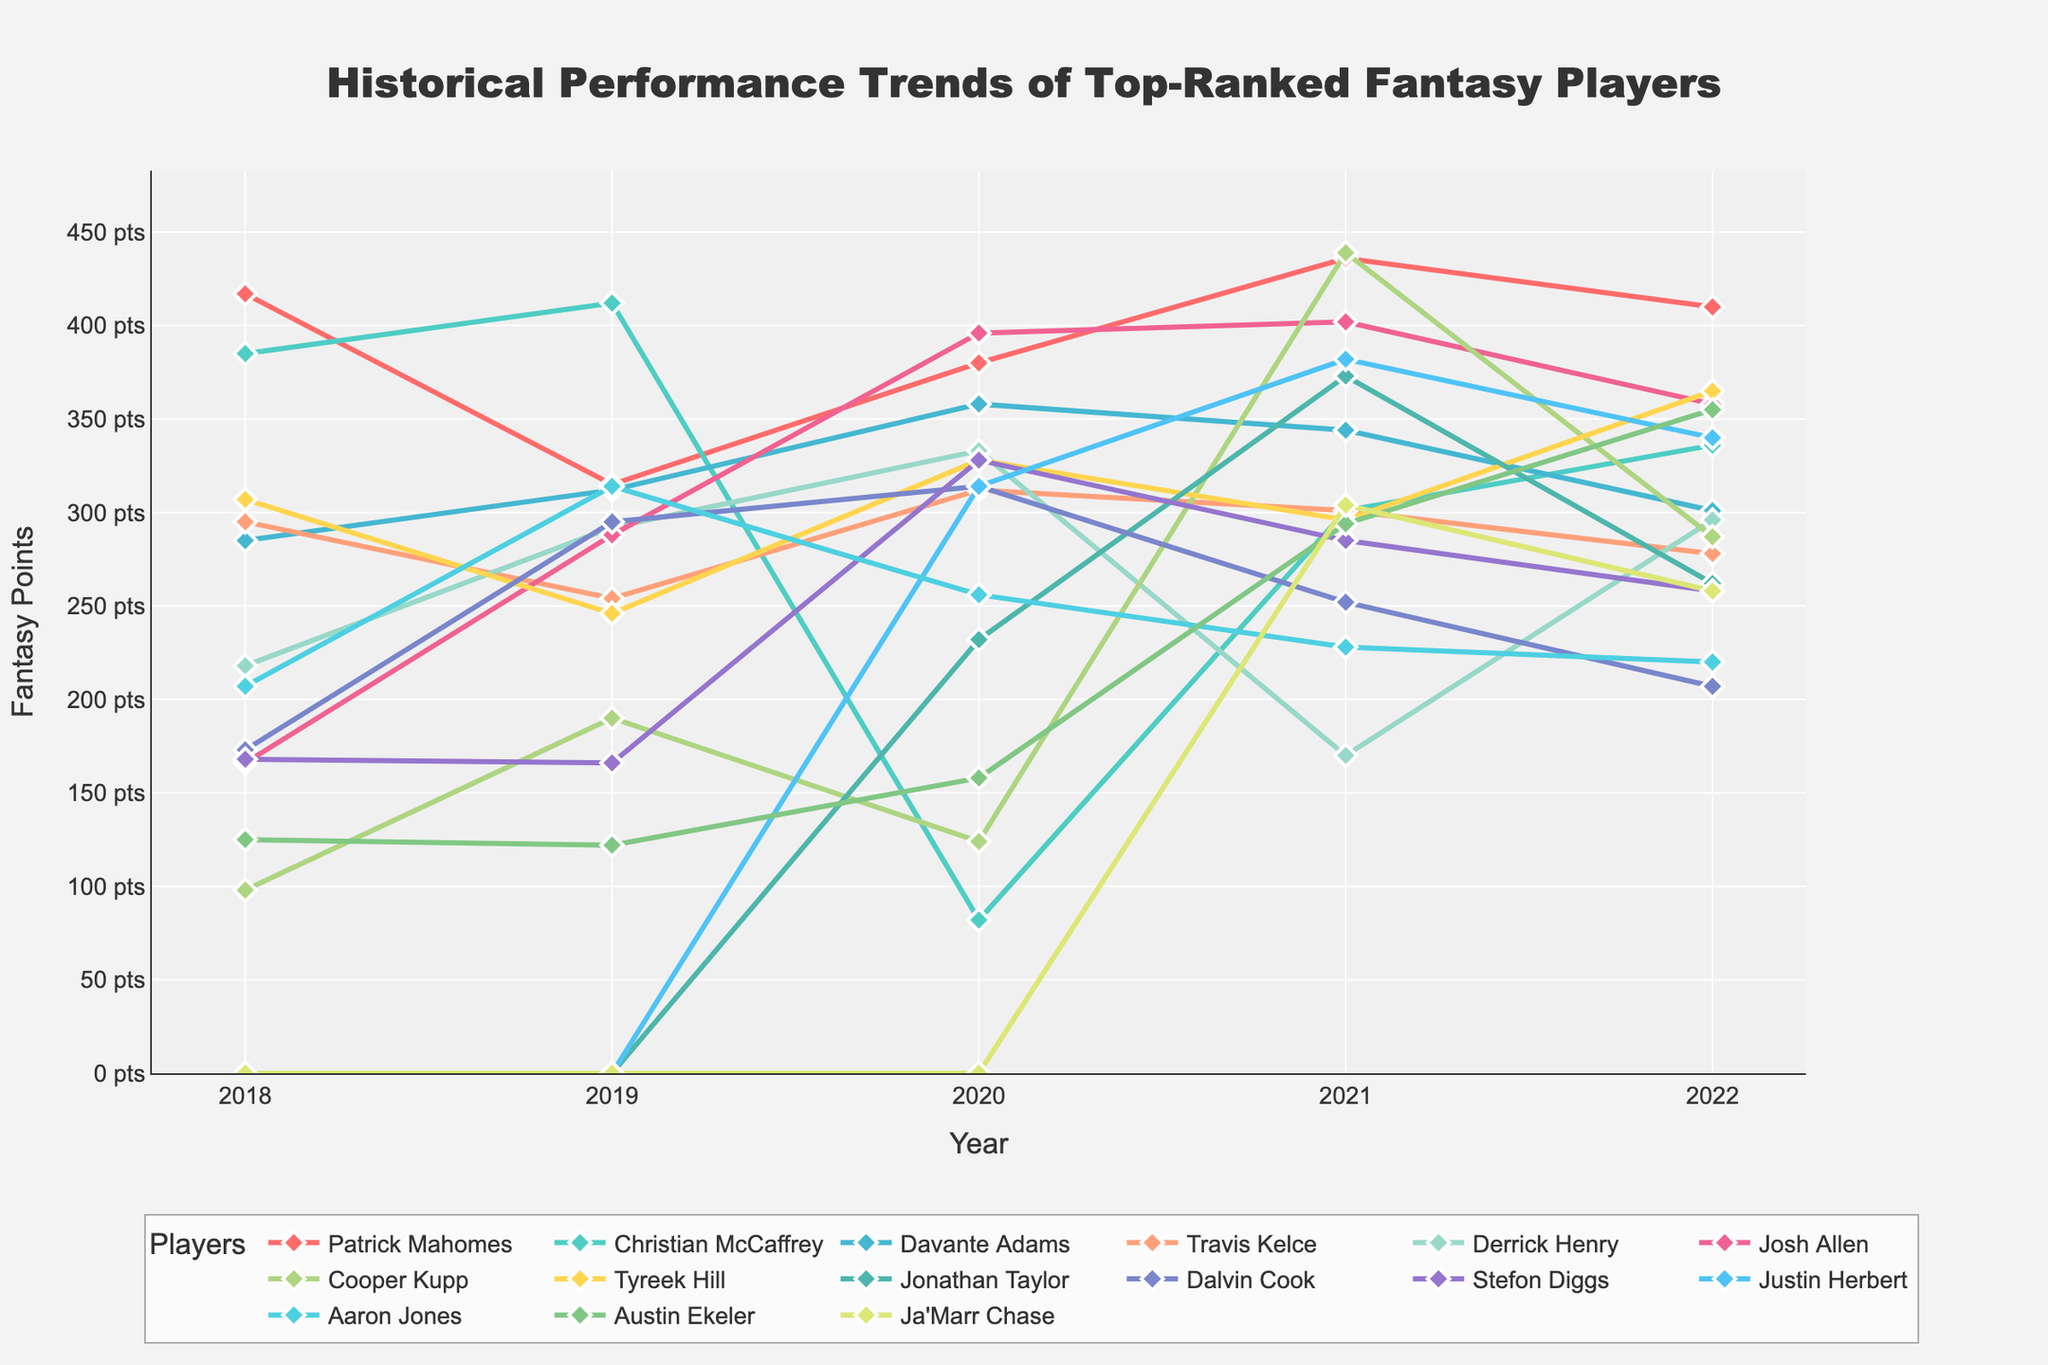How did Patrick Mahomes' fantasy points change from 2018 to 2019? From the chart, we can see Patrick Mahomes in 2018 had 417 points and in 2019 had 315 points, so the change is 315 - 417 = -102 points.
Answer: -102 points Which player had the largest increase in fantasy points from 2020 to 2021? Observing the chart, we find that Cooper Kupp had a dramatic increase from 124 points in 2020 to 439 points in 2021, an increase of 315 points.
Answer: Cooper Kupp Who scored more fantasy points in 2022, Josh Allen or Justin Herbert? Looking at the chart, Josh Allen scored 358 points in 2022, while Justin Herbert scored 340 points.
Answer: Josh Allen Between Tyreek Hill and Davante Adams, who had more consistent fantasy points over the years from 2018 to 2022? By examining the fluctuations in the lines, Davante Adams' points are more consistent (less variation) from year to year compared to Tyreek Hill.
Answer: Davante Adams What is the average fantasy points scored by Derrick Henry over the five years? The points for Derrick Henry over the years are 218, 292, 333, 170, and 296. Averaging these: (218 + 292 + 333 + 170 + 296) / 5 = 261.8.
Answer: 261.8 Who had a higher peak fantasy score over the five-year period, Christian McCaffrey or Austin Ekeler? From the chart, Christian McCaffrey's peak was 412 points (2019), and Austin Ekeler's peak was 355 points (2022).
Answer: Christian McCaffrey What was the combined total of fantasy points for Patrick Mahomes and Josh Allen in the year 2021? The points in 2021 for Patrick Mahomes were 436 and for Josh Allen 402. Summing these: 436 + 402 = 838.
Answer: 838 How did the performance trend for Ja'Marr Chase compare between his first two years (2021 and 2022)? Ja'Marr Chase scored 304 points in 2021 and 258 points in 2022, showing a decrease of 304 - 258 = 46 points.
Answer: Decrease of 46 points Which player had the sharpest decline in points in any single year? Observing the chart, Christian McCaffrey declined from 412 points in 2019 to 82 points in 2020, a decline of 330 points.
Answer: Christian McCaffrey 